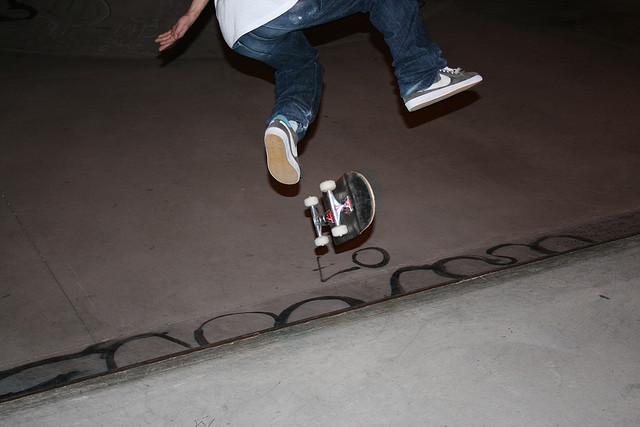What are the two letters shown on the ground?
Short answer required. Lo. How well used is the skateboard?
Be succinct. Very used. How many wheels can you see in the picture?
Give a very brief answer. 4. What sport is shown?
Concise answer only. Skateboarding. What color are the axles?
Give a very brief answer. Silver. What color is the man's pants?
Answer briefly. Blue. Is the man standing on the skateboard?
Keep it brief. No. What does the bottom of the skateboard say?
Be succinct. Nothing. What type of paint was used on the ground?
Concise answer only. Spray. 